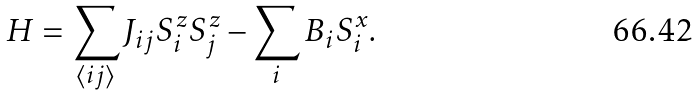Convert formula to latex. <formula><loc_0><loc_0><loc_500><loc_500>H = \sum _ { \langle i j \rangle } J _ { i j } S _ { i } ^ { z } S _ { j } ^ { z } - \sum _ { i } B _ { i } S _ { i } ^ { x } .</formula> 